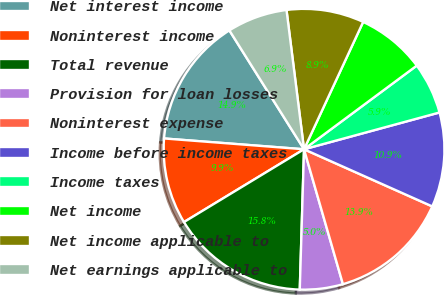Convert chart. <chart><loc_0><loc_0><loc_500><loc_500><pie_chart><fcel>Net interest income<fcel>Noninterest income<fcel>Total revenue<fcel>Provision for loan losses<fcel>Noninterest expense<fcel>Income before income taxes<fcel>Income taxes<fcel>Net income<fcel>Net income applicable to<fcel>Net earnings applicable to<nl><fcel>14.85%<fcel>9.9%<fcel>15.84%<fcel>4.95%<fcel>13.86%<fcel>10.89%<fcel>5.94%<fcel>7.92%<fcel>8.91%<fcel>6.93%<nl></chart> 